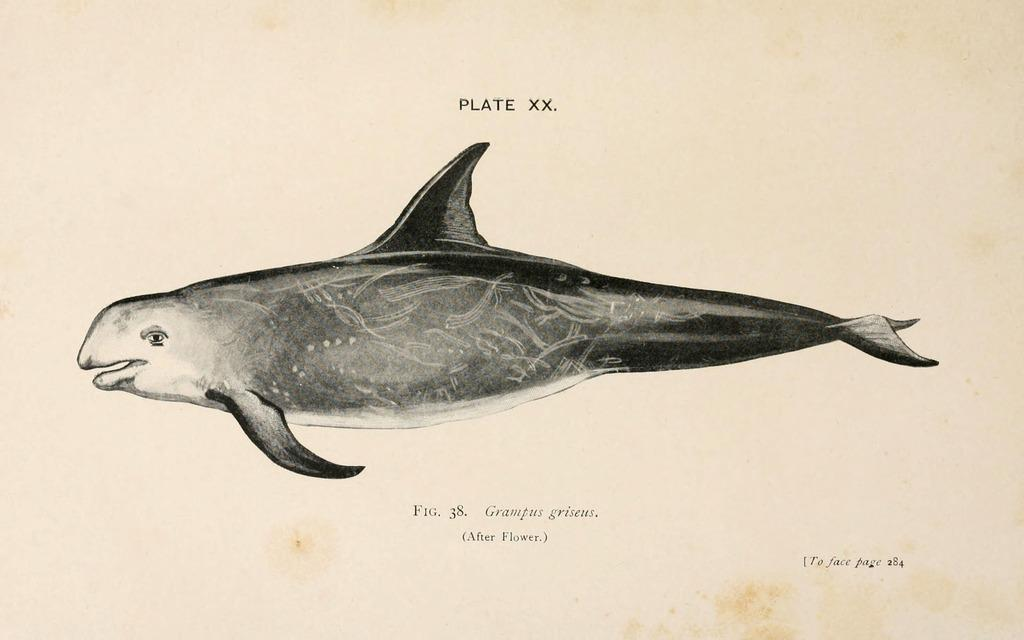What is the main subject of the image on the page? The main subject of the image on the page is a fish. What else can be found on the page besides the image? There is text on the page. Where is the farm located in the image? There is no farm present in the image; it features an image of a fish and text. What type of trick is being performed in the image? There is no trick being performed in the image; it features an image of a fish and text. 